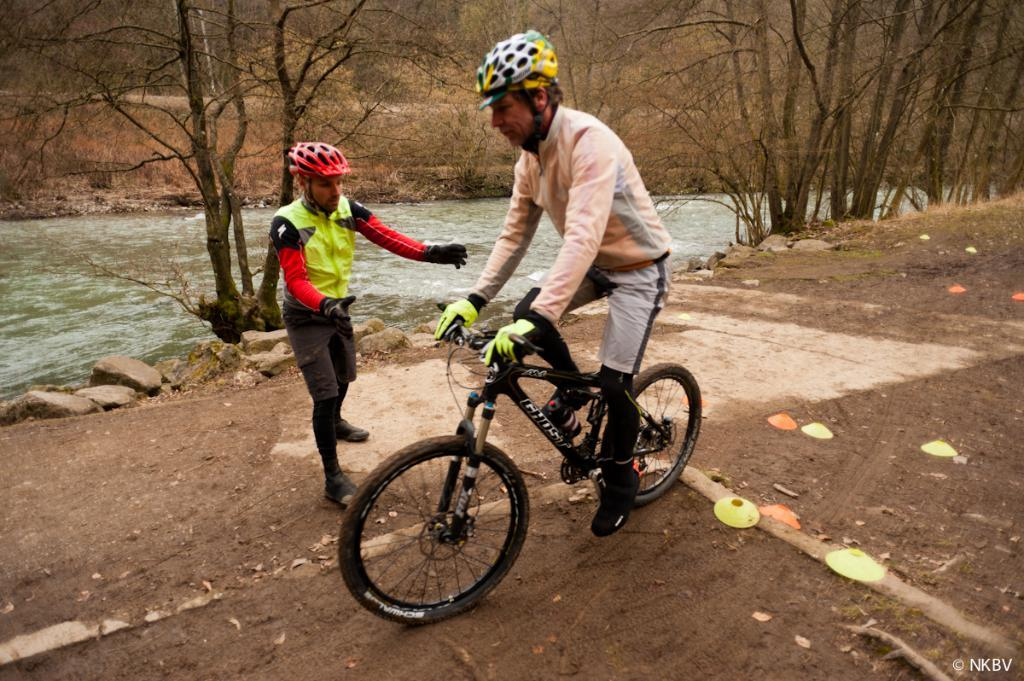What is the main subject of the image? There is a person riding a cycle in the image. Can you describe the person's companion in the image? There is another person standing beside the cyclist. What can be seen in the background of the image? There are trees and a lake in the background of the image. What type of fish can be seen swimming in the lake in the image? There is no fish visible in the image; only the lake is present in the background. 